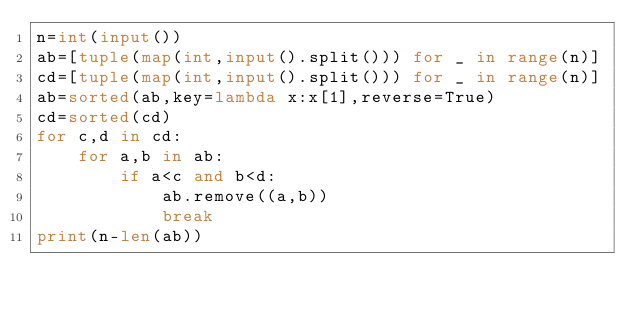Convert code to text. <code><loc_0><loc_0><loc_500><loc_500><_Python_>n=int(input())
ab=[tuple(map(int,input().split())) for _ in range(n)]
cd=[tuple(map(int,input().split())) for _ in range(n)]
ab=sorted(ab,key=lambda x:x[1],reverse=True)
cd=sorted(cd)
for c,d in cd:
    for a,b in ab:
        if a<c and b<d:
            ab.remove((a,b))
            break
print(n-len(ab))</code> 